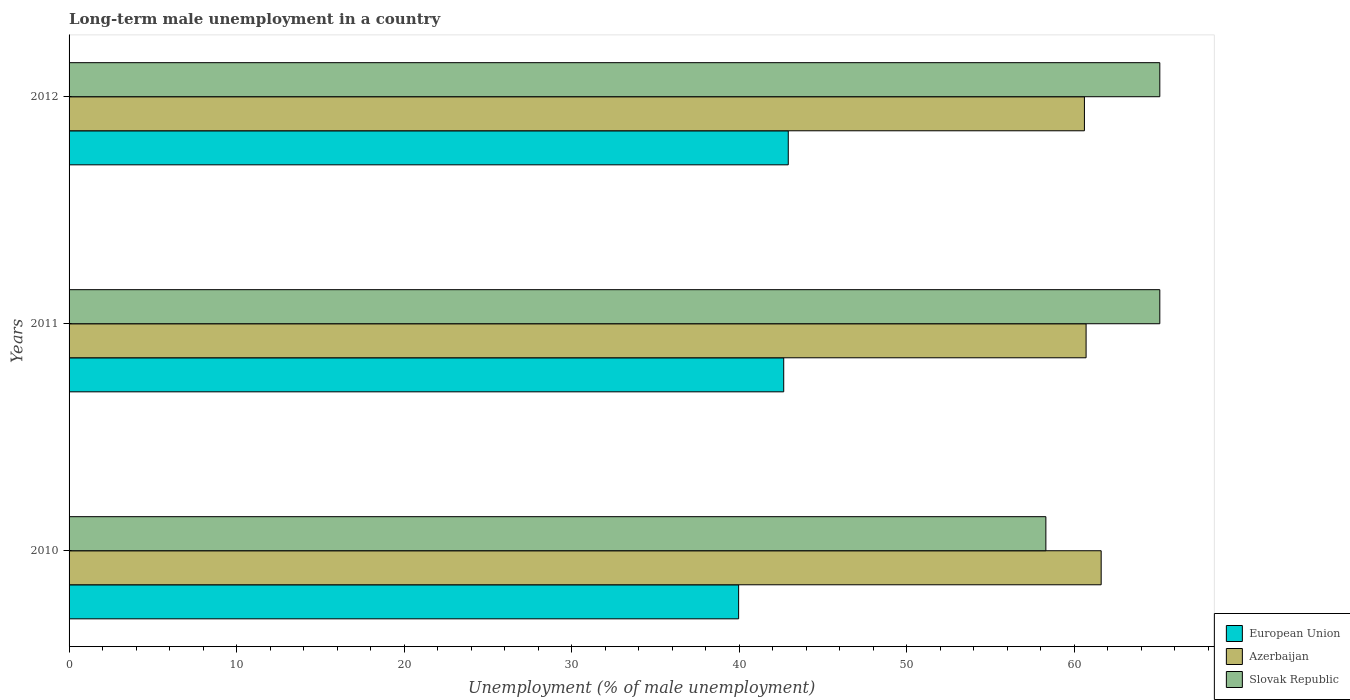How many groups of bars are there?
Offer a terse response. 3. Are the number of bars per tick equal to the number of legend labels?
Ensure brevity in your answer.  Yes. Are the number of bars on each tick of the Y-axis equal?
Your answer should be very brief. Yes. How many bars are there on the 1st tick from the top?
Provide a short and direct response. 3. How many bars are there on the 3rd tick from the bottom?
Keep it short and to the point. 3. In how many cases, is the number of bars for a given year not equal to the number of legend labels?
Offer a very short reply. 0. What is the percentage of long-term unemployed male population in European Union in 2012?
Offer a very short reply. 42.92. Across all years, what is the maximum percentage of long-term unemployed male population in Azerbaijan?
Keep it short and to the point. 61.6. Across all years, what is the minimum percentage of long-term unemployed male population in European Union?
Your response must be concise. 39.96. In which year was the percentage of long-term unemployed male population in Azerbaijan maximum?
Your answer should be compact. 2010. In which year was the percentage of long-term unemployed male population in European Union minimum?
Offer a terse response. 2010. What is the total percentage of long-term unemployed male population in Azerbaijan in the graph?
Make the answer very short. 182.9. What is the difference between the percentage of long-term unemployed male population in European Union in 2010 and that in 2012?
Your response must be concise. -2.96. What is the difference between the percentage of long-term unemployed male population in Slovak Republic in 2010 and the percentage of long-term unemployed male population in European Union in 2012?
Your answer should be compact. 15.38. What is the average percentage of long-term unemployed male population in Slovak Republic per year?
Your answer should be very brief. 62.83. In the year 2011, what is the difference between the percentage of long-term unemployed male population in European Union and percentage of long-term unemployed male population in Azerbaijan?
Offer a very short reply. -18.05. What is the ratio of the percentage of long-term unemployed male population in European Union in 2010 to that in 2012?
Your answer should be very brief. 0.93. What is the difference between the highest and the second highest percentage of long-term unemployed male population in Azerbaijan?
Make the answer very short. 0.9. What is the difference between the highest and the lowest percentage of long-term unemployed male population in Azerbaijan?
Your response must be concise. 1. In how many years, is the percentage of long-term unemployed male population in Slovak Republic greater than the average percentage of long-term unemployed male population in Slovak Republic taken over all years?
Your answer should be very brief. 2. Is the sum of the percentage of long-term unemployed male population in European Union in 2010 and 2012 greater than the maximum percentage of long-term unemployed male population in Azerbaijan across all years?
Give a very brief answer. Yes. What does the 1st bar from the top in 2010 represents?
Provide a short and direct response. Slovak Republic. What does the 1st bar from the bottom in 2012 represents?
Provide a succinct answer. European Union. How many bars are there?
Keep it short and to the point. 9. What is the difference between two consecutive major ticks on the X-axis?
Provide a short and direct response. 10. Does the graph contain grids?
Your answer should be very brief. No. How many legend labels are there?
Your answer should be compact. 3. What is the title of the graph?
Your answer should be compact. Long-term male unemployment in a country. Does "Guinea-Bissau" appear as one of the legend labels in the graph?
Ensure brevity in your answer.  No. What is the label or title of the X-axis?
Keep it short and to the point. Unemployment (% of male unemployment). What is the Unemployment (% of male unemployment) of European Union in 2010?
Give a very brief answer. 39.96. What is the Unemployment (% of male unemployment) in Azerbaijan in 2010?
Give a very brief answer. 61.6. What is the Unemployment (% of male unemployment) of Slovak Republic in 2010?
Make the answer very short. 58.3. What is the Unemployment (% of male unemployment) in European Union in 2011?
Ensure brevity in your answer.  42.65. What is the Unemployment (% of male unemployment) of Azerbaijan in 2011?
Your answer should be compact. 60.7. What is the Unemployment (% of male unemployment) of Slovak Republic in 2011?
Your answer should be compact. 65.1. What is the Unemployment (% of male unemployment) of European Union in 2012?
Offer a terse response. 42.92. What is the Unemployment (% of male unemployment) in Azerbaijan in 2012?
Your response must be concise. 60.6. What is the Unemployment (% of male unemployment) of Slovak Republic in 2012?
Your answer should be compact. 65.1. Across all years, what is the maximum Unemployment (% of male unemployment) in European Union?
Provide a succinct answer. 42.92. Across all years, what is the maximum Unemployment (% of male unemployment) of Azerbaijan?
Your answer should be very brief. 61.6. Across all years, what is the maximum Unemployment (% of male unemployment) in Slovak Republic?
Keep it short and to the point. 65.1. Across all years, what is the minimum Unemployment (% of male unemployment) of European Union?
Provide a succinct answer. 39.96. Across all years, what is the minimum Unemployment (% of male unemployment) of Azerbaijan?
Provide a succinct answer. 60.6. Across all years, what is the minimum Unemployment (% of male unemployment) in Slovak Republic?
Ensure brevity in your answer.  58.3. What is the total Unemployment (% of male unemployment) in European Union in the graph?
Your answer should be compact. 125.54. What is the total Unemployment (% of male unemployment) of Azerbaijan in the graph?
Make the answer very short. 182.9. What is the total Unemployment (% of male unemployment) of Slovak Republic in the graph?
Offer a terse response. 188.5. What is the difference between the Unemployment (% of male unemployment) in European Union in 2010 and that in 2011?
Your response must be concise. -2.69. What is the difference between the Unemployment (% of male unemployment) in Slovak Republic in 2010 and that in 2011?
Make the answer very short. -6.8. What is the difference between the Unemployment (% of male unemployment) in European Union in 2010 and that in 2012?
Your answer should be compact. -2.96. What is the difference between the Unemployment (% of male unemployment) of European Union in 2011 and that in 2012?
Make the answer very short. -0.27. What is the difference between the Unemployment (% of male unemployment) in Azerbaijan in 2011 and that in 2012?
Make the answer very short. 0.1. What is the difference between the Unemployment (% of male unemployment) in European Union in 2010 and the Unemployment (% of male unemployment) in Azerbaijan in 2011?
Provide a succinct answer. -20.74. What is the difference between the Unemployment (% of male unemployment) in European Union in 2010 and the Unemployment (% of male unemployment) in Slovak Republic in 2011?
Give a very brief answer. -25.14. What is the difference between the Unemployment (% of male unemployment) of European Union in 2010 and the Unemployment (% of male unemployment) of Azerbaijan in 2012?
Make the answer very short. -20.64. What is the difference between the Unemployment (% of male unemployment) of European Union in 2010 and the Unemployment (% of male unemployment) of Slovak Republic in 2012?
Keep it short and to the point. -25.14. What is the difference between the Unemployment (% of male unemployment) in European Union in 2011 and the Unemployment (% of male unemployment) in Azerbaijan in 2012?
Make the answer very short. -17.95. What is the difference between the Unemployment (% of male unemployment) of European Union in 2011 and the Unemployment (% of male unemployment) of Slovak Republic in 2012?
Provide a succinct answer. -22.45. What is the average Unemployment (% of male unemployment) of European Union per year?
Offer a terse response. 41.85. What is the average Unemployment (% of male unemployment) in Azerbaijan per year?
Offer a terse response. 60.97. What is the average Unemployment (% of male unemployment) of Slovak Republic per year?
Provide a short and direct response. 62.83. In the year 2010, what is the difference between the Unemployment (% of male unemployment) in European Union and Unemployment (% of male unemployment) in Azerbaijan?
Make the answer very short. -21.64. In the year 2010, what is the difference between the Unemployment (% of male unemployment) of European Union and Unemployment (% of male unemployment) of Slovak Republic?
Ensure brevity in your answer.  -18.34. In the year 2010, what is the difference between the Unemployment (% of male unemployment) in Azerbaijan and Unemployment (% of male unemployment) in Slovak Republic?
Your response must be concise. 3.3. In the year 2011, what is the difference between the Unemployment (% of male unemployment) in European Union and Unemployment (% of male unemployment) in Azerbaijan?
Your answer should be very brief. -18.05. In the year 2011, what is the difference between the Unemployment (% of male unemployment) of European Union and Unemployment (% of male unemployment) of Slovak Republic?
Your response must be concise. -22.45. In the year 2011, what is the difference between the Unemployment (% of male unemployment) in Azerbaijan and Unemployment (% of male unemployment) in Slovak Republic?
Your response must be concise. -4.4. In the year 2012, what is the difference between the Unemployment (% of male unemployment) of European Union and Unemployment (% of male unemployment) of Azerbaijan?
Offer a very short reply. -17.68. In the year 2012, what is the difference between the Unemployment (% of male unemployment) of European Union and Unemployment (% of male unemployment) of Slovak Republic?
Offer a very short reply. -22.18. What is the ratio of the Unemployment (% of male unemployment) in European Union in 2010 to that in 2011?
Your answer should be compact. 0.94. What is the ratio of the Unemployment (% of male unemployment) of Azerbaijan in 2010 to that in 2011?
Your answer should be very brief. 1.01. What is the ratio of the Unemployment (% of male unemployment) of Slovak Republic in 2010 to that in 2011?
Provide a short and direct response. 0.9. What is the ratio of the Unemployment (% of male unemployment) of Azerbaijan in 2010 to that in 2012?
Make the answer very short. 1.02. What is the ratio of the Unemployment (% of male unemployment) of Slovak Republic in 2010 to that in 2012?
Ensure brevity in your answer.  0.9. What is the ratio of the Unemployment (% of male unemployment) in Slovak Republic in 2011 to that in 2012?
Make the answer very short. 1. What is the difference between the highest and the second highest Unemployment (% of male unemployment) of European Union?
Make the answer very short. 0.27. What is the difference between the highest and the lowest Unemployment (% of male unemployment) of European Union?
Offer a terse response. 2.96. 